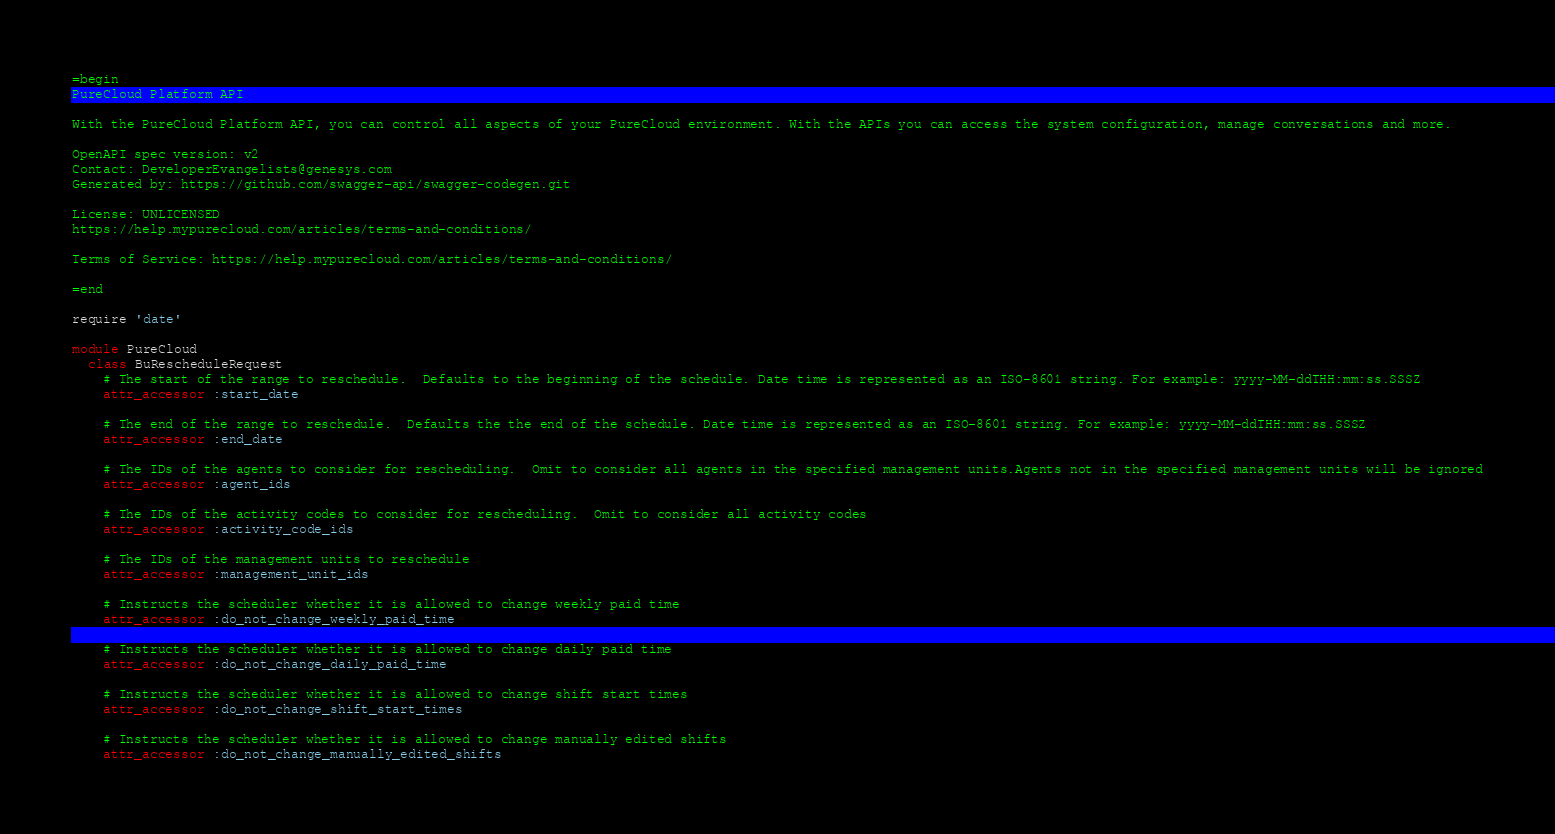Convert code to text. <code><loc_0><loc_0><loc_500><loc_500><_Ruby_>=begin
PureCloud Platform API

With the PureCloud Platform API, you can control all aspects of your PureCloud environment. With the APIs you can access the system configuration, manage conversations and more.

OpenAPI spec version: v2
Contact: DeveloperEvangelists@genesys.com
Generated by: https://github.com/swagger-api/swagger-codegen.git

License: UNLICENSED
https://help.mypurecloud.com/articles/terms-and-conditions/

Terms of Service: https://help.mypurecloud.com/articles/terms-and-conditions/

=end

require 'date'

module PureCloud
  class BuRescheduleRequest
    # The start of the range to reschedule.  Defaults to the beginning of the schedule. Date time is represented as an ISO-8601 string. For example: yyyy-MM-ddTHH:mm:ss.SSSZ
    attr_accessor :start_date

    # The end of the range to reschedule.  Defaults the the end of the schedule. Date time is represented as an ISO-8601 string. For example: yyyy-MM-ddTHH:mm:ss.SSSZ
    attr_accessor :end_date

    # The IDs of the agents to consider for rescheduling.  Omit to consider all agents in the specified management units.Agents not in the specified management units will be ignored
    attr_accessor :agent_ids

    # The IDs of the activity codes to consider for rescheduling.  Omit to consider all activity codes
    attr_accessor :activity_code_ids

    # The IDs of the management units to reschedule
    attr_accessor :management_unit_ids

    # Instructs the scheduler whether it is allowed to change weekly paid time
    attr_accessor :do_not_change_weekly_paid_time

    # Instructs the scheduler whether it is allowed to change daily paid time
    attr_accessor :do_not_change_daily_paid_time

    # Instructs the scheduler whether it is allowed to change shift start times
    attr_accessor :do_not_change_shift_start_times

    # Instructs the scheduler whether it is allowed to change manually edited shifts
    attr_accessor :do_not_change_manually_edited_shifts
</code> 